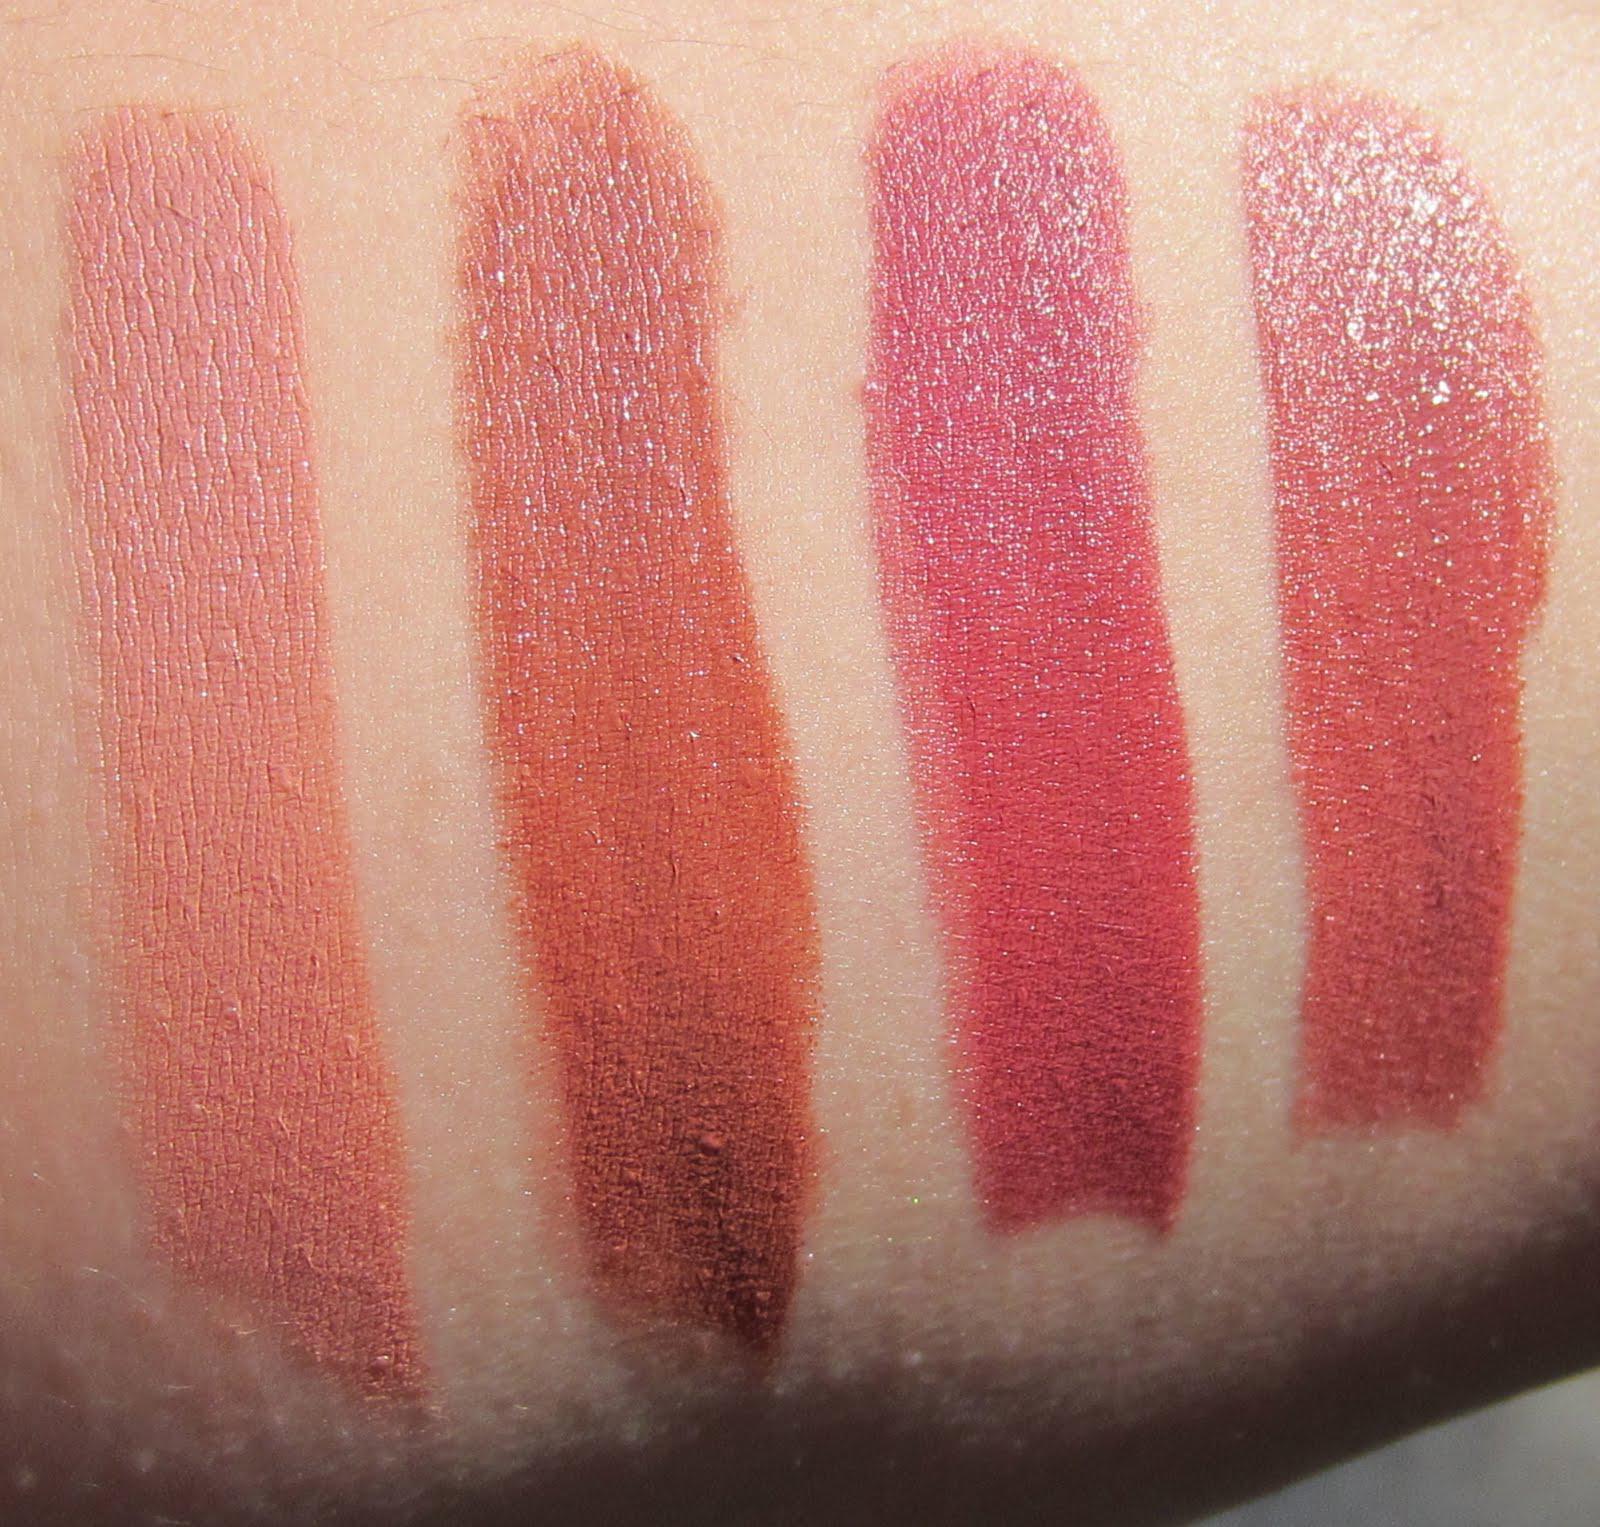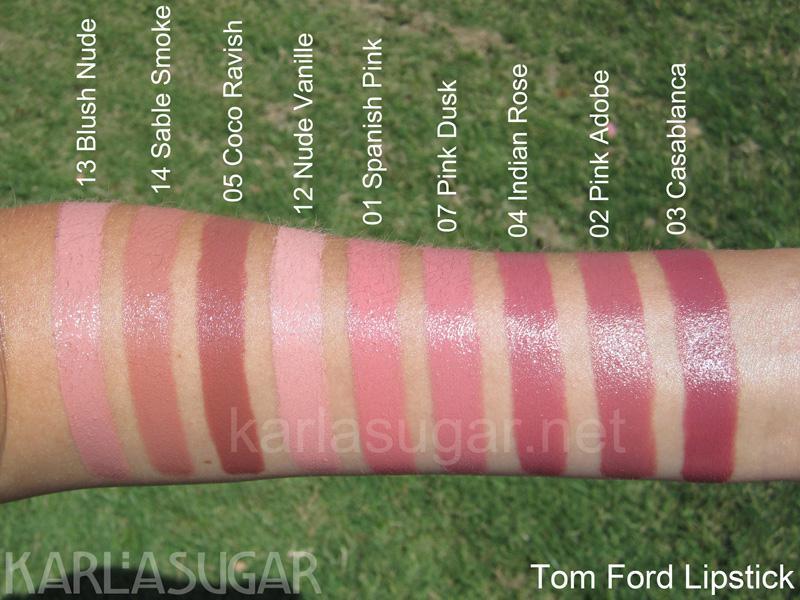The first image is the image on the left, the second image is the image on the right. For the images shown, is this caption "There are at least 3 tubes of lipstick in these." true? Answer yes or no. No. The first image is the image on the left, the second image is the image on the right. Analyze the images presented: Is the assertion "There are multiple lines of lip stick color on an arm." valid? Answer yes or no. Yes. 